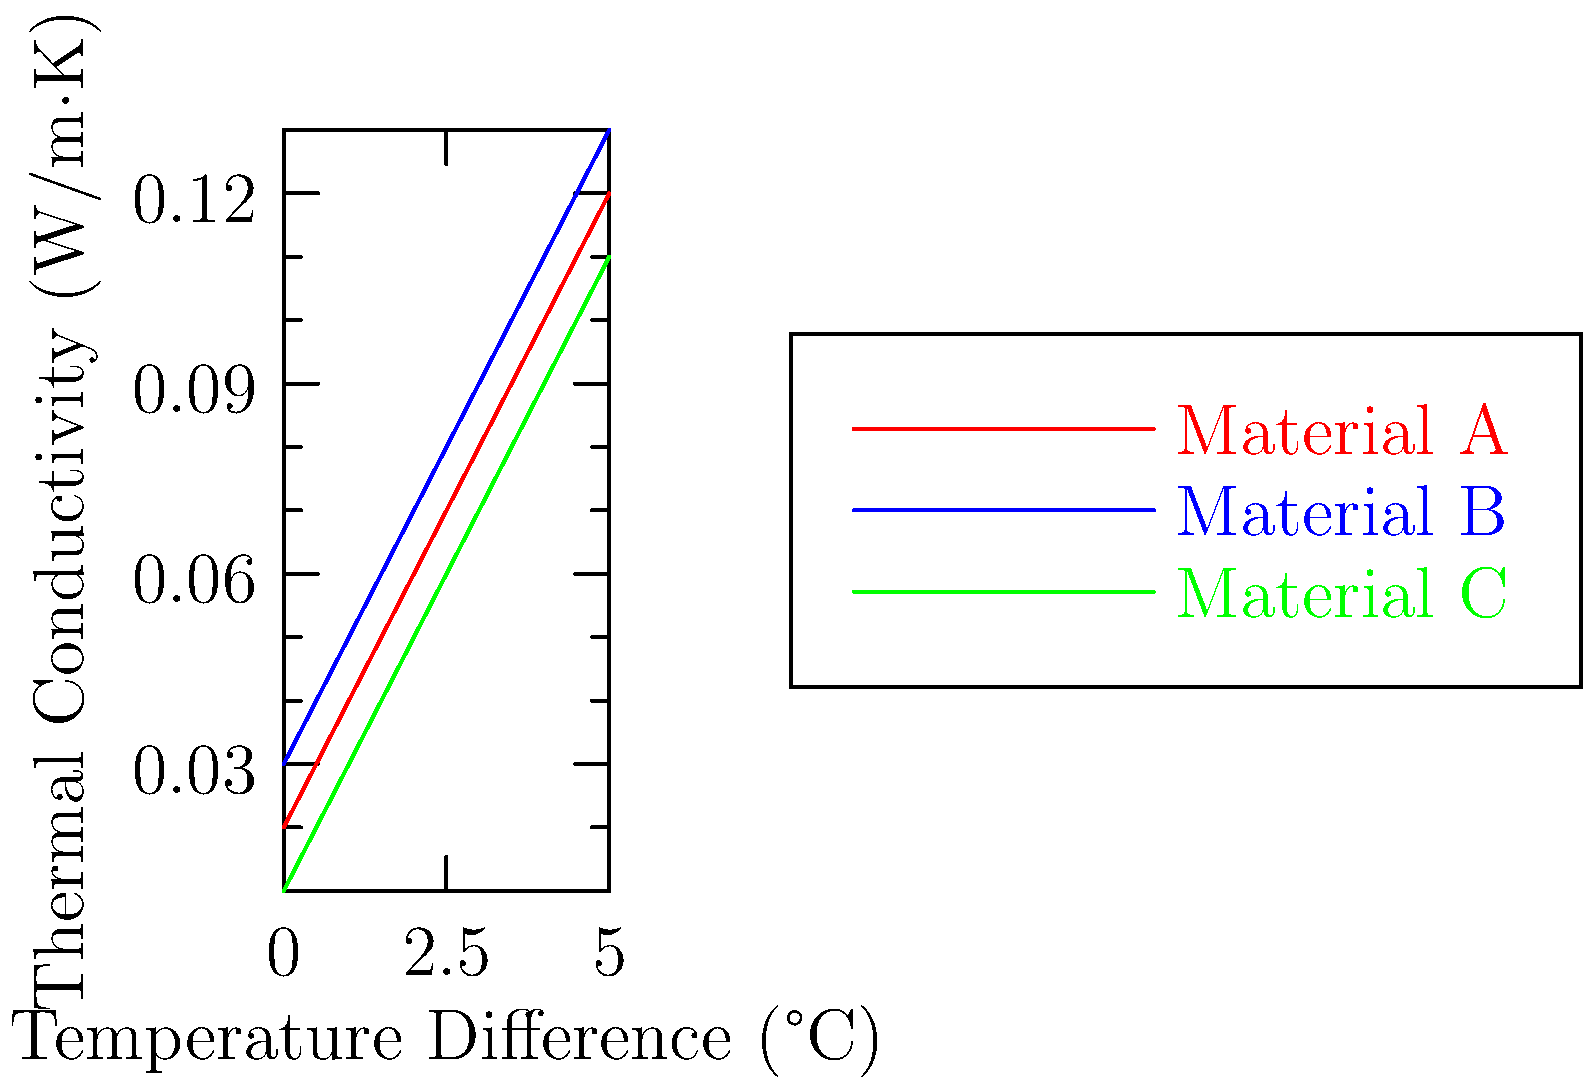Given the thermal conductivity graphs for three insulation materials (A, B, and C) as a function of temperature difference, quantitatively analyze which material would be most effective for minimizing heat transfer in a scenario where the temperature difference is 4°C. Provide a numerical justification for your answer. To determine the most effective insulation material for minimizing heat transfer, we need to compare the thermal conductivities of the materials at the given temperature difference of 4°C. Lower thermal conductivity indicates better insulation properties.

Step 1: Identify the thermal conductivity values at 4°C temperature difference:
Material A: $k_A = 0.10$ W/m·K
Material B: $k_B = 0.11$ W/m·K
Material C: $k_C = 0.09$ W/m·K

Step 2: Compare the thermal conductivity values:
$k_C < k_A < k_B$

Step 3: Calculate the percentage difference in thermal conductivity between Material C and the next best option (Material A):

Percentage difference = $\frac{k_A - k_C}{k_C} \times 100\%$
$= \frac{0.10 - 0.09}{0.09} \times 100\% \approx 11.11\%$

Step 4: Interpret the results:
Material C has the lowest thermal conductivity at 4°C temperature difference, making it the most effective for minimizing heat transfer. It is approximately 11.11% more effective than the next best option (Material A) in reducing heat transfer at the given temperature difference.
Answer: Material C; 11.11% more effective than next best option. 